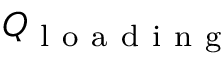<formula> <loc_0><loc_0><loc_500><loc_500>Q _ { l o a d i n g }</formula> 